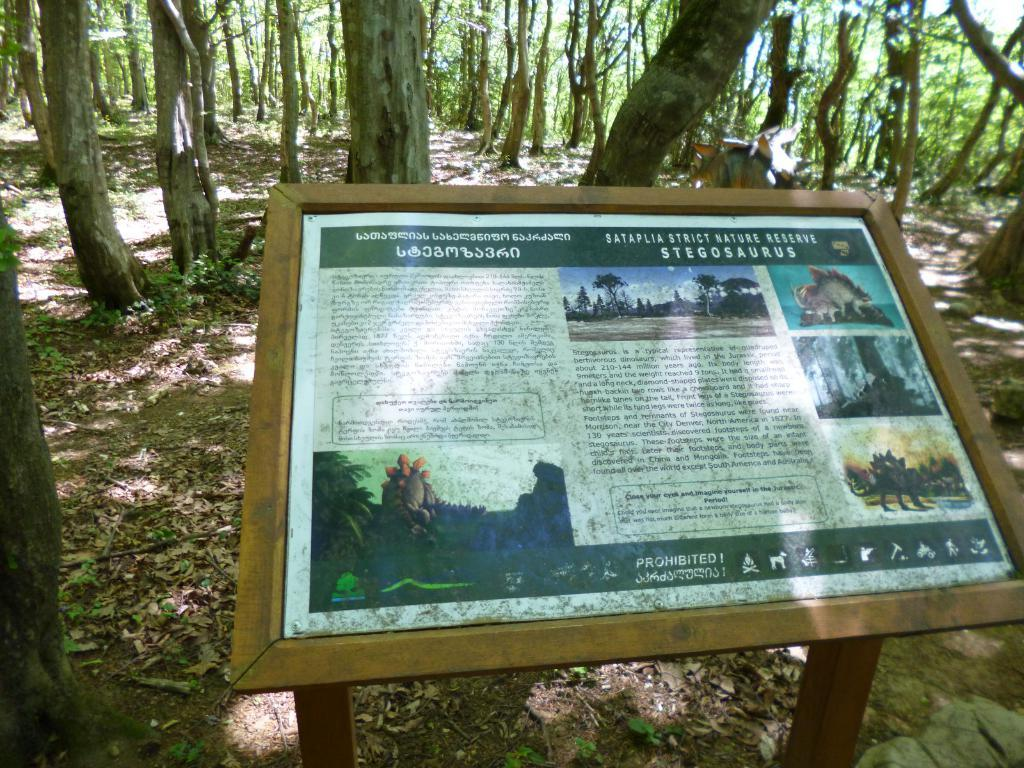What is the main object in the image? There is a newspaper in the image. What else can be seen in the image besides the newspaper? Dry leaves and trees are present in the image. Can you describe the newspaper in more detail? There is writing on the newspaper. How does the crook affect the trees in the image? There is no crook present in the image, so it cannot affect the trees. What type of earthquake can be seen in the image? There is no earthquake present in the image; it is a still image of a newspaper, dry leaves, and trees. 